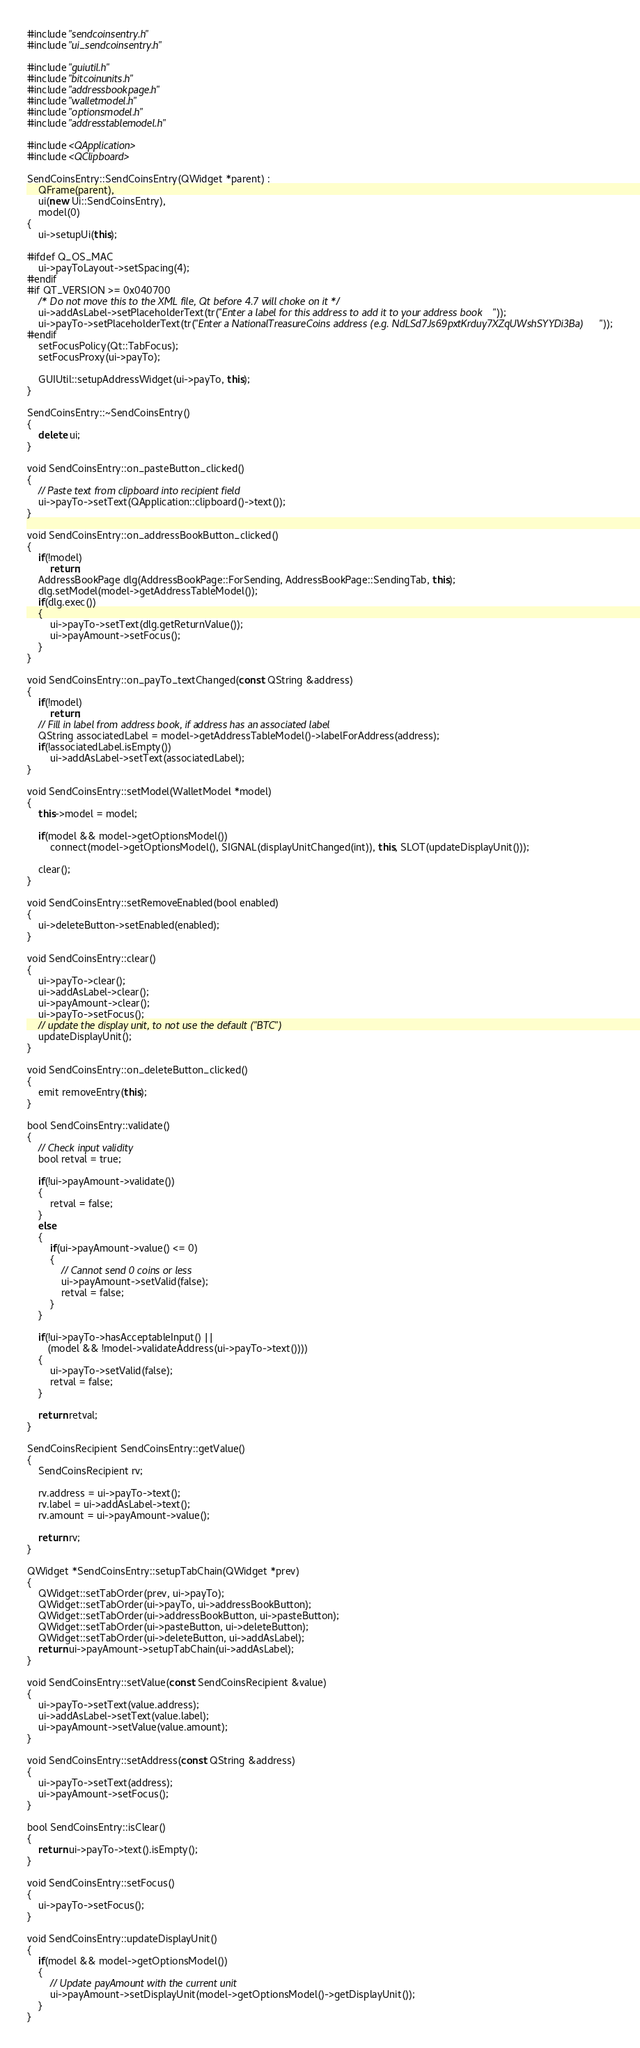Convert code to text. <code><loc_0><loc_0><loc_500><loc_500><_C++_>#include "sendcoinsentry.h"
#include "ui_sendcoinsentry.h"

#include "guiutil.h"
#include "bitcoinunits.h"
#include "addressbookpage.h"
#include "walletmodel.h"
#include "optionsmodel.h"
#include "addresstablemodel.h"

#include <QApplication>
#include <QClipboard>

SendCoinsEntry::SendCoinsEntry(QWidget *parent) :
    QFrame(parent),
    ui(new Ui::SendCoinsEntry),
    model(0)
{
    ui->setupUi(this);

#ifdef Q_OS_MAC
    ui->payToLayout->setSpacing(4);
#endif
#if QT_VERSION >= 0x040700
    /* Do not move this to the XML file, Qt before 4.7 will choke on it */
    ui->addAsLabel->setPlaceholderText(tr("Enter a label for this address to add it to your address book"));
    ui->payTo->setPlaceholderText(tr("Enter a NationalTreasureCoins address (e.g. NdLSd7Js69pxtKrduy7XZqUWshSYYDi3Ba)"));
#endif
    setFocusPolicy(Qt::TabFocus);
    setFocusProxy(ui->payTo);

    GUIUtil::setupAddressWidget(ui->payTo, this);
}

SendCoinsEntry::~SendCoinsEntry()
{
    delete ui;
}

void SendCoinsEntry::on_pasteButton_clicked()
{
    // Paste text from clipboard into recipient field
    ui->payTo->setText(QApplication::clipboard()->text());
}

void SendCoinsEntry::on_addressBookButton_clicked()
{
    if(!model)
        return;
    AddressBookPage dlg(AddressBookPage::ForSending, AddressBookPage::SendingTab, this);
    dlg.setModel(model->getAddressTableModel());
    if(dlg.exec())
    {
        ui->payTo->setText(dlg.getReturnValue());
        ui->payAmount->setFocus();
    }
}

void SendCoinsEntry::on_payTo_textChanged(const QString &address)
{
    if(!model)
        return;
    // Fill in label from address book, if address has an associated label
    QString associatedLabel = model->getAddressTableModel()->labelForAddress(address);
    if(!associatedLabel.isEmpty())
        ui->addAsLabel->setText(associatedLabel);
}

void SendCoinsEntry::setModel(WalletModel *model)
{
    this->model = model;

    if(model && model->getOptionsModel())
        connect(model->getOptionsModel(), SIGNAL(displayUnitChanged(int)), this, SLOT(updateDisplayUnit()));

    clear();
}

void SendCoinsEntry::setRemoveEnabled(bool enabled)
{
    ui->deleteButton->setEnabled(enabled);
}

void SendCoinsEntry::clear()
{
    ui->payTo->clear();
    ui->addAsLabel->clear();
    ui->payAmount->clear();
    ui->payTo->setFocus();
    // update the display unit, to not use the default ("BTC")
    updateDisplayUnit();
}

void SendCoinsEntry::on_deleteButton_clicked()
{
    emit removeEntry(this);
}

bool SendCoinsEntry::validate()
{
    // Check input validity
    bool retval = true;

    if(!ui->payAmount->validate())
    {
        retval = false;
    }
    else
    {
        if(ui->payAmount->value() <= 0)
        {
            // Cannot send 0 coins or less
            ui->payAmount->setValid(false);
            retval = false;
        }
    }

    if(!ui->payTo->hasAcceptableInput() ||
       (model && !model->validateAddress(ui->payTo->text())))
    {
        ui->payTo->setValid(false);
        retval = false;
    }

    return retval;
}

SendCoinsRecipient SendCoinsEntry::getValue()
{
    SendCoinsRecipient rv;

    rv.address = ui->payTo->text();
    rv.label = ui->addAsLabel->text();
    rv.amount = ui->payAmount->value();

    return rv;
}

QWidget *SendCoinsEntry::setupTabChain(QWidget *prev)
{
    QWidget::setTabOrder(prev, ui->payTo);
    QWidget::setTabOrder(ui->payTo, ui->addressBookButton);
    QWidget::setTabOrder(ui->addressBookButton, ui->pasteButton);
    QWidget::setTabOrder(ui->pasteButton, ui->deleteButton);
    QWidget::setTabOrder(ui->deleteButton, ui->addAsLabel);
    return ui->payAmount->setupTabChain(ui->addAsLabel);
}

void SendCoinsEntry::setValue(const SendCoinsRecipient &value)
{
    ui->payTo->setText(value.address);
    ui->addAsLabel->setText(value.label);
    ui->payAmount->setValue(value.amount);
}

void SendCoinsEntry::setAddress(const QString &address)
{
    ui->payTo->setText(address);
    ui->payAmount->setFocus();
}

bool SendCoinsEntry::isClear()
{
    return ui->payTo->text().isEmpty();
}

void SendCoinsEntry::setFocus()
{
    ui->payTo->setFocus();
}

void SendCoinsEntry::updateDisplayUnit()
{
    if(model && model->getOptionsModel())
    {
        // Update payAmount with the current unit
        ui->payAmount->setDisplayUnit(model->getOptionsModel()->getDisplayUnit());
    }
}
</code> 